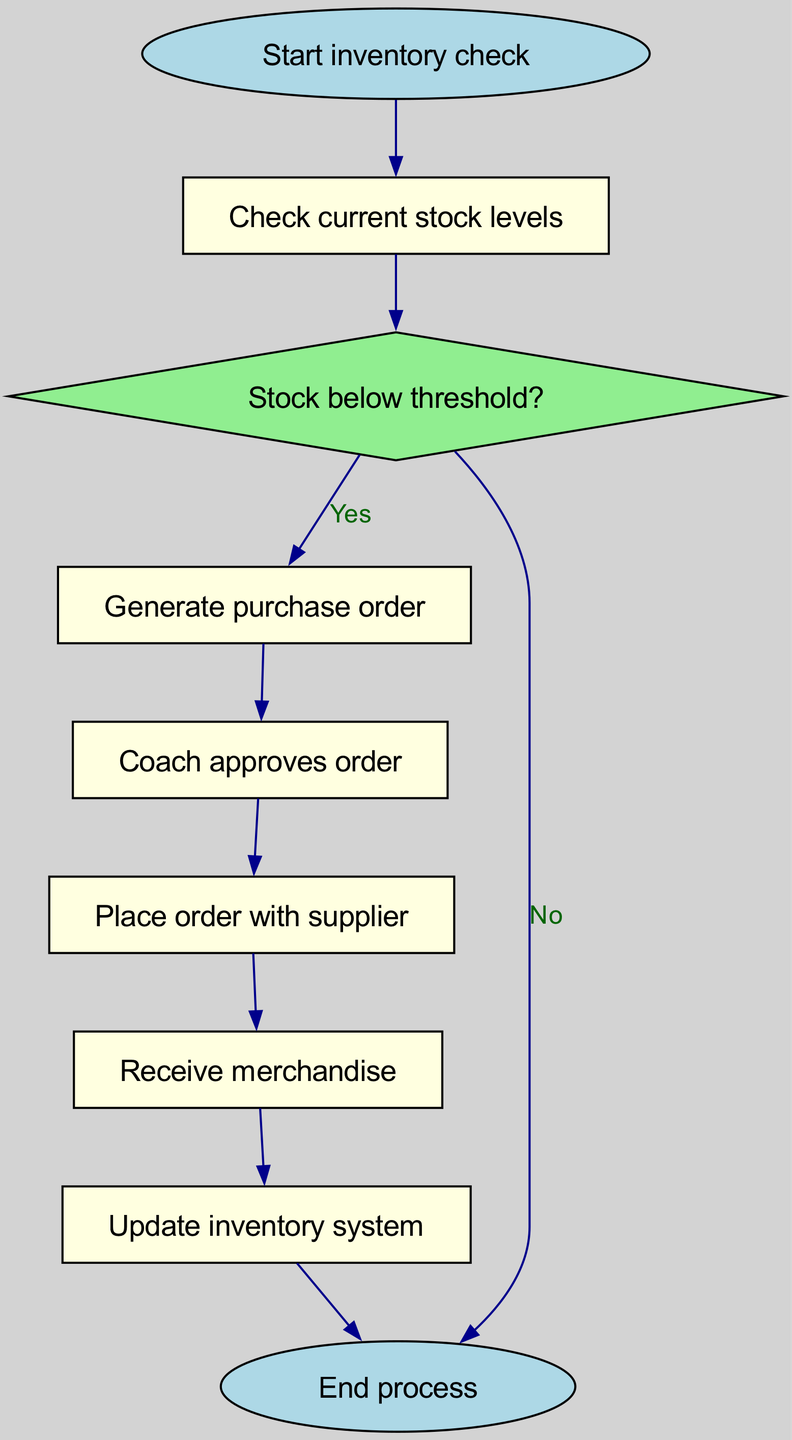What is the starting point of the process? The starting point of the process is indicated as "Start inventory check," which is the first node in the flowchart.
Answer: Start inventory check How many nodes are in the diagram? To determine the number of nodes, we simply count the nodes listed in the "nodes" section of the data, which totals to nine distinct nodes.
Answer: Nine Which node represents the approval step? The node that represents the approval step in the inventory management process is labeled "Coach approves order." This is the step that follows the order generation.
Answer: Coach approves order What happens if the stock is not below the threshold? If the stock is not below the threshold, the flowchart indicates that the next action is to end the process, as represented in the edge that leads from "below_threshold" to "end" with the label "No."
Answer: End process How does the order from the coach proceed after approval? After the coach approves the order, the next step in the flowchart is to "Place order with supplier," indicating that the order is submitted to the supplier for processing.
Answer: Place order with supplier What shape is used to depict a decision in this flowchart? A diamond shape represents a decision point in the flowchart, specifically illustrated by the node "Stock below threshold?" which requires a yes/no determination.
Answer: Diamond What is the last step of the inventory management process? The last step of the inventory management process is indicated as "End process," which signifies that the procedure has been completed after updating the inventory system.
Answer: End process After placing the order, what is the next node? After placing the order with the supplier, the next node is "Receive merchandise," which indicates the process of waiting to get the ordered items.
Answer: Receive merchandise What do you do if the stock levels are adequate? If the stock levels are adequate, the flowchart indicates that the process will go to the "end" node instead of generating an order, as shown in the edge labeled "No."
Answer: End process 